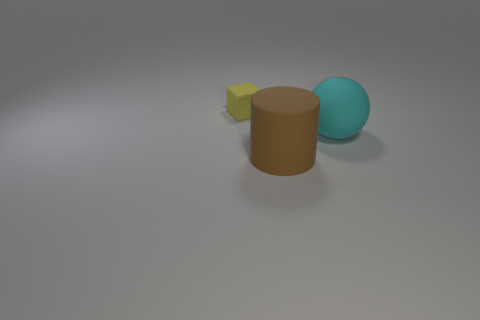Subtract all purple cubes. Subtract all cyan balls. How many cubes are left? 1 Add 1 big brown matte things. How many objects exist? 4 Subtract all cubes. How many objects are left? 2 Subtract 0 gray balls. How many objects are left? 3 Subtract all red balls. Subtract all tiny objects. How many objects are left? 2 Add 3 big matte things. How many big matte things are left? 5 Add 2 big cyan rubber spheres. How many big cyan rubber spheres exist? 3 